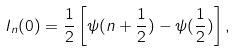<formula> <loc_0><loc_0><loc_500><loc_500>I _ { n } ( 0 ) = \frac { 1 } { 2 } \left [ \psi ( n + \frac { 1 } { 2 } ) - \psi ( \frac { 1 } { 2 } ) \right ] ,</formula> 